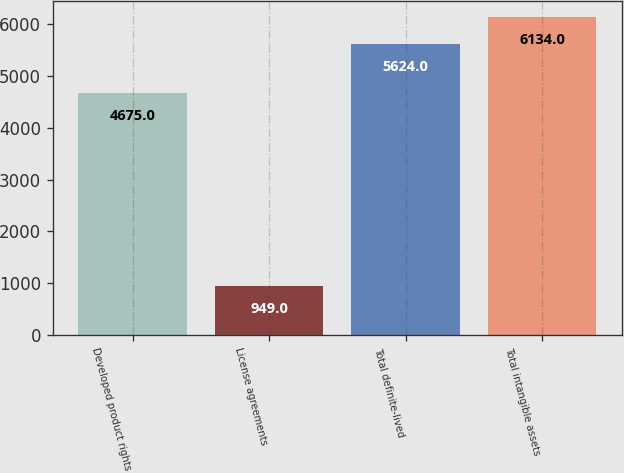Convert chart to OTSL. <chart><loc_0><loc_0><loc_500><loc_500><bar_chart><fcel>Developed product rights<fcel>License agreements<fcel>Total definite-lived<fcel>Total intangible assets<nl><fcel>4675<fcel>949<fcel>5624<fcel>6134<nl></chart> 